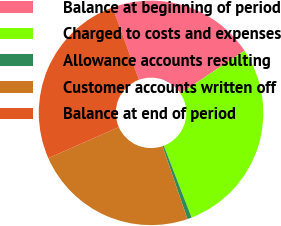Convert chart to OTSL. <chart><loc_0><loc_0><loc_500><loc_500><pie_chart><fcel>Balance at beginning of period<fcel>Charged to costs and expenses<fcel>Allowance accounts resulting<fcel>Customer accounts written off<fcel>Balance at end of period<nl><fcel>21.23%<fcel>28.46%<fcel>0.62%<fcel>23.64%<fcel>26.05%<nl></chart> 